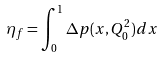<formula> <loc_0><loc_0><loc_500><loc_500>\eta _ { f } = \int _ { 0 } ^ { 1 } \Delta p ( x , Q _ { 0 } ^ { 2 } ) d x</formula> 